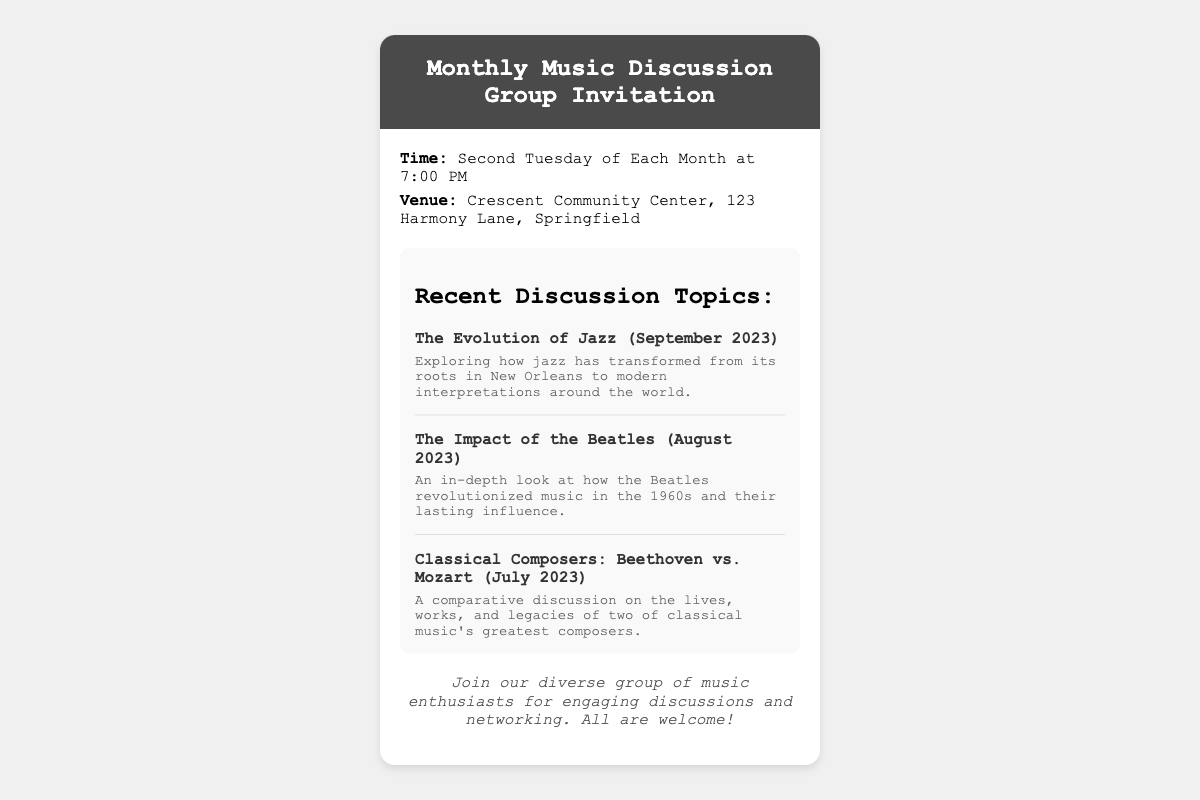What is the meeting time? The meeting time is specified in the information section of the document, which states it is the second Tuesday of each month at 7:00 PM.
Answer: Second Tuesday of Each Month at 7:00 PM Where is the venue located? The venue for the gathering is mentioned in the document as the Crescent Community Center, 123 Harmony Lane, Springfield.
Answer: Crescent Community Center, 123 Harmony Lane, Springfield What topic was discussed in September 2023? The document lists the recent discussion topics, and September 2023's topic is "The Evolution of Jazz."
Answer: The Evolution of Jazz Which month focused on the Beatles? The document shows that the discussion topic for August 2023 was about the Beatles and their impact on music.
Answer: August 2023 What type of discussions can participants expect? The additional information section indicates that the group will have engaging discussions and networking opportunities.
Answer: Engaging discussions and networking How many recent discussion topics are listed? The document provides three recent discussion topics within the topics section.
Answer: Three What is the primary purpose of the invitation? The additional information suggests the invitation is aimed at inviting music enthusiasts to join the group for discussions.
Answer: Inviting music enthusiasts What color is the header background? The header's background color is mentioned as a dark shade, specifically #4a4a4a.
Answer: #4a4a4a 